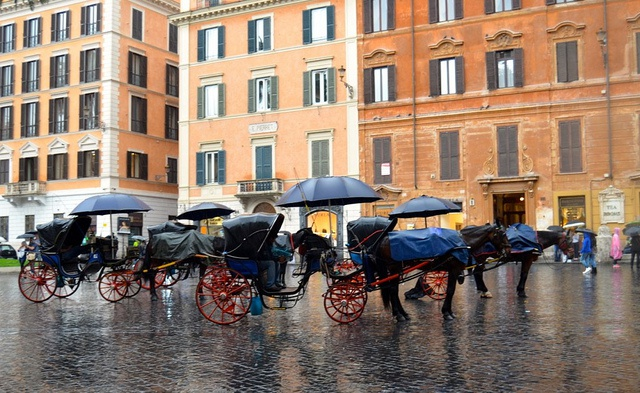Describe the objects in this image and their specific colors. I can see horse in black, navy, gray, and darkblue tones, horse in black, gray, maroon, and navy tones, horse in black, gray, and purple tones, umbrella in black, gray, and darkgray tones, and umbrella in black, gray, and darkgray tones in this image. 